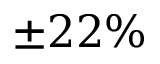Convert formula to latex. <formula><loc_0><loc_0><loc_500><loc_500>\pm 2 2 \%</formula> 